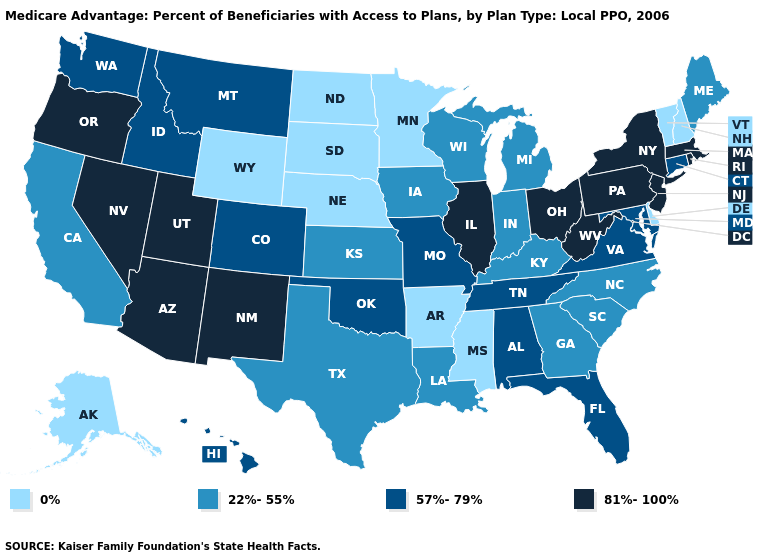What is the highest value in states that border Connecticut?
Quick response, please. 81%-100%. Which states have the lowest value in the USA?
Concise answer only. Alaska, Arkansas, Delaware, Minnesota, Mississippi, North Dakota, Nebraska, New Hampshire, South Dakota, Vermont, Wyoming. Among the states that border New Mexico , does Arizona have the lowest value?
Answer briefly. No. Does the first symbol in the legend represent the smallest category?
Answer briefly. Yes. What is the value of Connecticut?
Keep it brief. 57%-79%. What is the value of Maryland?
Give a very brief answer. 57%-79%. What is the highest value in the USA?
Give a very brief answer. 81%-100%. What is the highest value in the Northeast ?
Quick response, please. 81%-100%. What is the lowest value in states that border Washington?
Quick response, please. 57%-79%. What is the value of North Carolina?
Concise answer only. 22%-55%. What is the lowest value in the USA?
Short answer required. 0%. What is the value of Florida?
Quick response, please. 57%-79%. Among the states that border Kentucky , which have the lowest value?
Keep it brief. Indiana. Is the legend a continuous bar?
Give a very brief answer. No. Name the states that have a value in the range 81%-100%?
Answer briefly. Arizona, Illinois, Massachusetts, New Jersey, New Mexico, Nevada, New York, Ohio, Oregon, Pennsylvania, Rhode Island, Utah, West Virginia. 